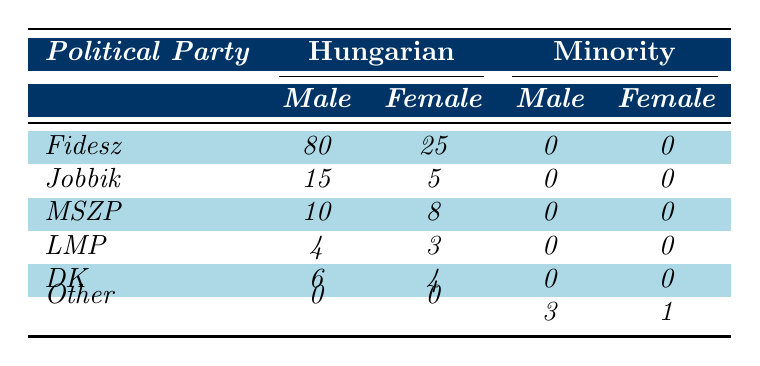What is the total number of representatives for the Fidesz party? Fidesz has 80 male representatives and 25 female representatives. Adding these, 80 + 25 = 105.
Answer: 105 What is the number of female representatives from the Jobbik party? There are 5 female representatives from the Jobbik party as shown in the table.
Answer: 5 What is the difference in the number of male representatives between Fidesz and MSZP? Fidesz has 80 male representatives and MSZP has 10 male representatives. The difference is 80 - 10 = 70.
Answer: 70 How many total representatives are there from minority ethnicities? The table shows 2 male and 1 female representative from the Romani and 1 male from the German. Adding these, 2 + 1 + 1 = 4.
Answer: 4 Is the number of female representatives from DK greater than that from LMP? DK has 4 female representatives while LMP has 3 female representatives. Since 4 > 3, the statement is true.
Answer: Yes What percentage of the total male representatives are from the Fidesz party? Total male representatives: 80 (Fidesz) + 15 (Jobbik) + 10 (MSZP) + 4 (LMP) + 6 (DK) + 2 (Romani) + 1 (German) = 118. Fidesz has 80 male representatives. The percentage is (80/118) * 100 ≈ 67.8%.
Answer: 67.8% Compare the total number of female representatives from Other party to that of DK. The Other party has 1 female representative, while DK has 4 female representatives. Comparing these, 1 < 4.
Answer: No How many representatives are there in total from Jobbik? Jobbik has 15 male and 5 female representatives, so total representatives are 15 + 5 = 20.
Answer: 20 What proportion of all Hungarian representatives are female? Total Hungarian representatives = 80 (Fidesz) + 15 (Jobbik) + 10 (MSZP) + 4 (LMP) + 6 (DK) + 25 (Fidesz female) + 5 (Jobbik female) + 8 (MSZP female) + 3 (LMP female) + 4 (DK female) = 155. Female representatives: 25 + 5 + 8 + 3 + 4 = 45. The proportion is 45/155 ≈ 0.2903 or 29.03%.
Answer: 29.03% Which political party has the lowest number of representatives in total? The LMP party has 7 total representatives (4 male + 3 female), which is the lowest compared to others in the table.
Answer: LMP 